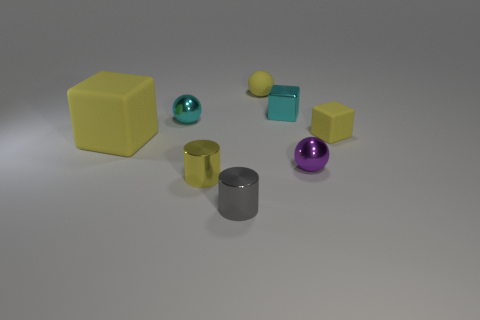How many other objects are there of the same color as the large object?
Give a very brief answer. 3. What number of things are small purple balls or purple shiny cubes?
Provide a succinct answer. 1. There is a cyan shiny object that is to the right of the yellow cylinder; is it the same shape as the yellow metallic object?
Offer a terse response. No. The metal sphere behind the object to the right of the tiny purple object is what color?
Give a very brief answer. Cyan. Is the number of tiny gray cylinders less than the number of tiny red metal spheres?
Your answer should be very brief. No. Are there any tiny cyan cylinders that have the same material as the small cyan ball?
Ensure brevity in your answer.  No. Is the shape of the purple metallic object the same as the cyan metallic object that is on the right side of the gray thing?
Ensure brevity in your answer.  No. Are there any yellow cubes in front of the purple metal object?
Your response must be concise. No. What number of gray metallic things have the same shape as the tiny yellow metal object?
Provide a succinct answer. 1. Are the big yellow thing and the yellow thing in front of the large thing made of the same material?
Ensure brevity in your answer.  No. 